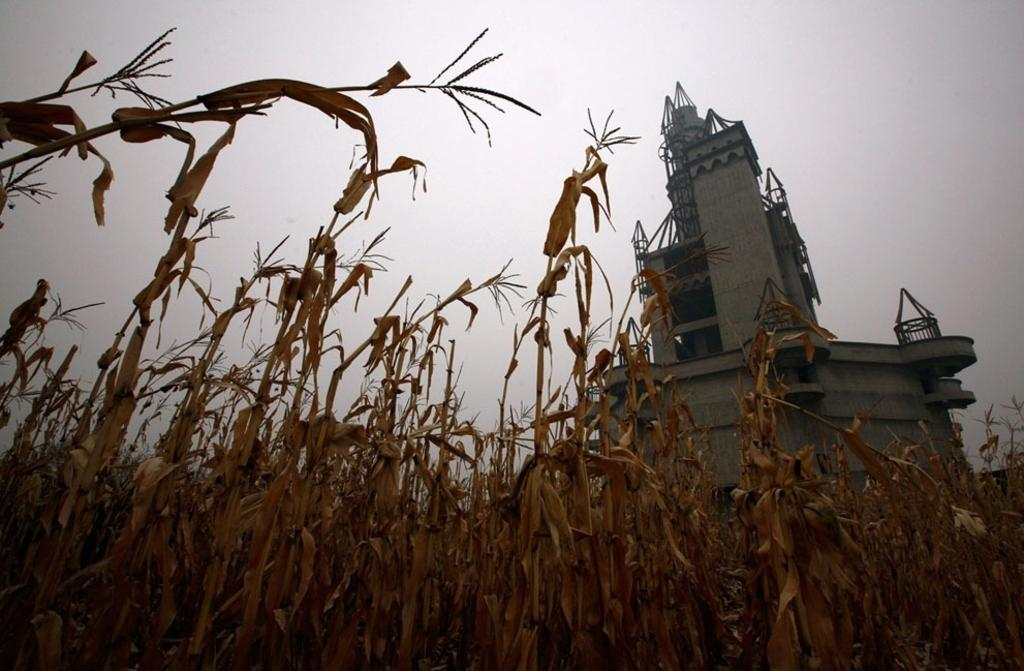What structure is located on the right side of the image? There is a building on the right side of the image. What type of vegetation is at the bottom of the image? There are plants at the bottom of the image. What is visible at the top of the image? The sky is visible at the top of the image. What type of creature is sitting on the rock in the image? There is no rock or creature present in the image. How many bags can be seen in the image? There are no bags present in the image. 